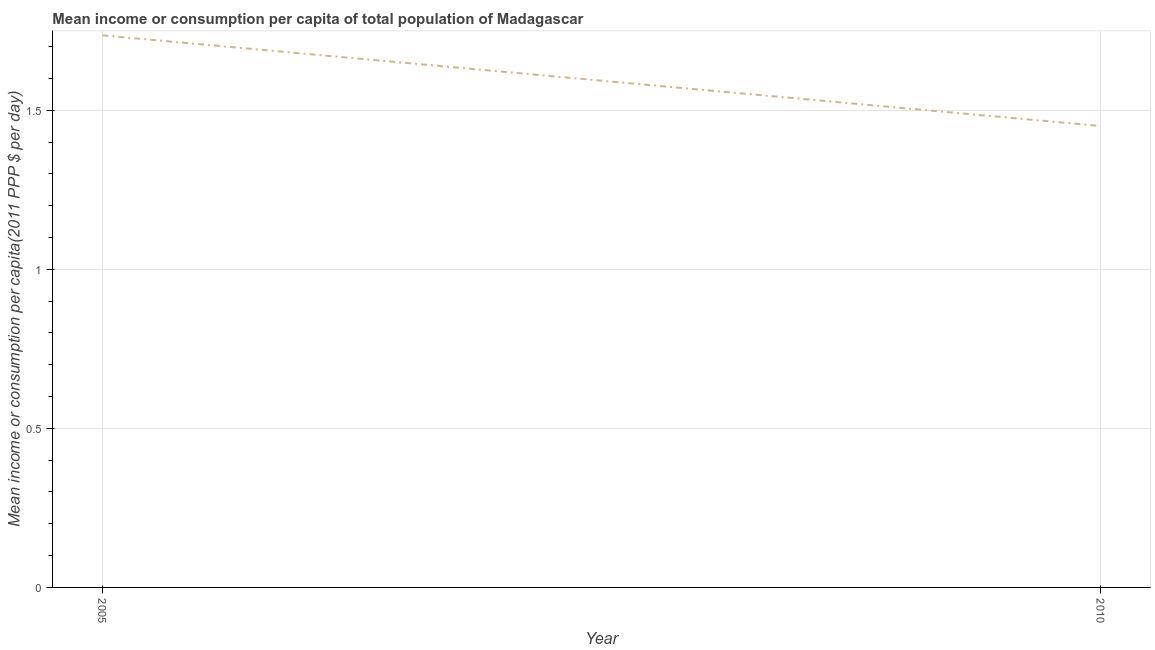What is the mean income or consumption in 2005?
Provide a short and direct response. 1.74. Across all years, what is the maximum mean income or consumption?
Offer a very short reply. 1.74. Across all years, what is the minimum mean income or consumption?
Offer a very short reply. 1.45. In which year was the mean income or consumption maximum?
Keep it short and to the point. 2005. In which year was the mean income or consumption minimum?
Offer a terse response. 2010. What is the sum of the mean income or consumption?
Offer a very short reply. 3.19. What is the difference between the mean income or consumption in 2005 and 2010?
Make the answer very short. 0.28. What is the average mean income or consumption per year?
Provide a short and direct response. 1.59. What is the median mean income or consumption?
Offer a very short reply. 1.59. Do a majority of the years between 2010 and 2005 (inclusive) have mean income or consumption greater than 0.4 $?
Your answer should be very brief. No. What is the ratio of the mean income or consumption in 2005 to that in 2010?
Ensure brevity in your answer.  1.2. Does the mean income or consumption monotonically increase over the years?
Ensure brevity in your answer.  No. Are the values on the major ticks of Y-axis written in scientific E-notation?
Your response must be concise. No. What is the title of the graph?
Provide a succinct answer. Mean income or consumption per capita of total population of Madagascar. What is the label or title of the X-axis?
Make the answer very short. Year. What is the label or title of the Y-axis?
Your answer should be very brief. Mean income or consumption per capita(2011 PPP $ per day). What is the Mean income or consumption per capita(2011 PPP $ per day) of 2005?
Your answer should be very brief. 1.74. What is the Mean income or consumption per capita(2011 PPP $ per day) in 2010?
Provide a short and direct response. 1.45. What is the difference between the Mean income or consumption per capita(2011 PPP $ per day) in 2005 and 2010?
Ensure brevity in your answer.  0.28. What is the ratio of the Mean income or consumption per capita(2011 PPP $ per day) in 2005 to that in 2010?
Your response must be concise. 1.2. 